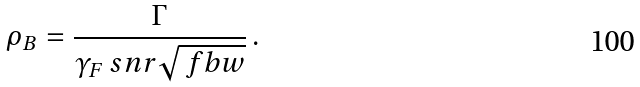<formula> <loc_0><loc_0><loc_500><loc_500>\rho _ { B } = \frac { \Gamma } { \gamma _ { F } \ s n r \sqrt { \ f b w } } \, .</formula> 